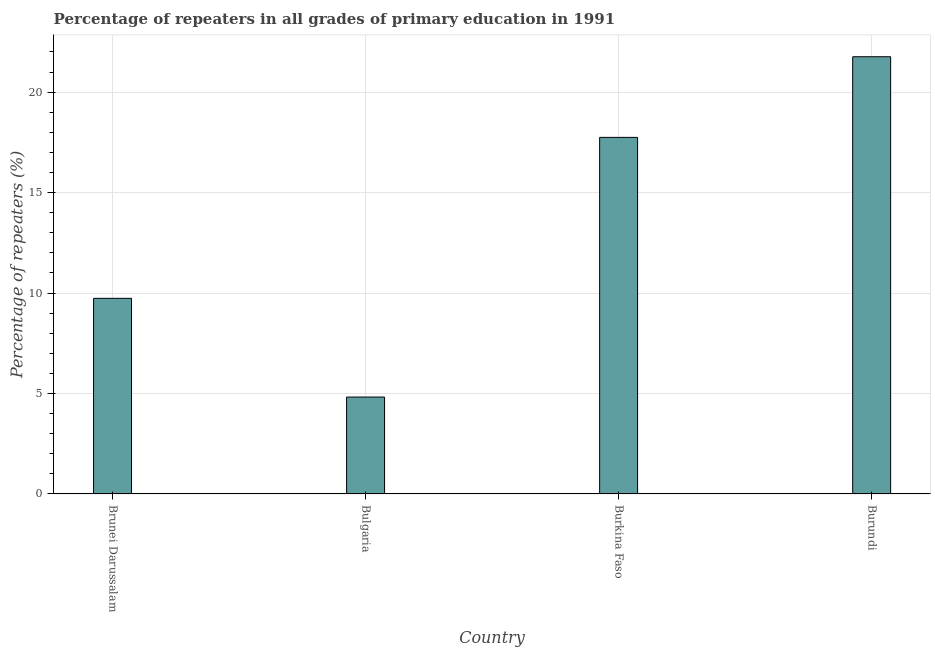Does the graph contain grids?
Offer a terse response. Yes. What is the title of the graph?
Offer a very short reply. Percentage of repeaters in all grades of primary education in 1991. What is the label or title of the Y-axis?
Ensure brevity in your answer.  Percentage of repeaters (%). What is the percentage of repeaters in primary education in Brunei Darussalam?
Offer a very short reply. 9.74. Across all countries, what is the maximum percentage of repeaters in primary education?
Keep it short and to the point. 21.76. Across all countries, what is the minimum percentage of repeaters in primary education?
Give a very brief answer. 4.82. In which country was the percentage of repeaters in primary education maximum?
Provide a succinct answer. Burundi. What is the sum of the percentage of repeaters in primary education?
Offer a terse response. 54.07. What is the difference between the percentage of repeaters in primary education in Brunei Darussalam and Burkina Faso?
Make the answer very short. -8.01. What is the average percentage of repeaters in primary education per country?
Your response must be concise. 13.52. What is the median percentage of repeaters in primary education?
Your answer should be very brief. 13.74. In how many countries, is the percentage of repeaters in primary education greater than 4 %?
Give a very brief answer. 4. What is the ratio of the percentage of repeaters in primary education in Brunei Darussalam to that in Burundi?
Provide a short and direct response. 0.45. Is the difference between the percentage of repeaters in primary education in Brunei Darussalam and Bulgaria greater than the difference between any two countries?
Make the answer very short. No. What is the difference between the highest and the second highest percentage of repeaters in primary education?
Give a very brief answer. 4.01. Is the sum of the percentage of repeaters in primary education in Bulgaria and Burkina Faso greater than the maximum percentage of repeaters in primary education across all countries?
Offer a terse response. Yes. What is the difference between the highest and the lowest percentage of repeaters in primary education?
Ensure brevity in your answer.  16.94. How many bars are there?
Offer a terse response. 4. Are all the bars in the graph horizontal?
Ensure brevity in your answer.  No. How many countries are there in the graph?
Ensure brevity in your answer.  4. What is the difference between two consecutive major ticks on the Y-axis?
Provide a short and direct response. 5. Are the values on the major ticks of Y-axis written in scientific E-notation?
Make the answer very short. No. What is the Percentage of repeaters (%) in Brunei Darussalam?
Your response must be concise. 9.74. What is the Percentage of repeaters (%) in Bulgaria?
Give a very brief answer. 4.82. What is the Percentage of repeaters (%) in Burkina Faso?
Make the answer very short. 17.75. What is the Percentage of repeaters (%) in Burundi?
Keep it short and to the point. 21.76. What is the difference between the Percentage of repeaters (%) in Brunei Darussalam and Bulgaria?
Make the answer very short. 4.91. What is the difference between the Percentage of repeaters (%) in Brunei Darussalam and Burkina Faso?
Your answer should be compact. -8.01. What is the difference between the Percentage of repeaters (%) in Brunei Darussalam and Burundi?
Keep it short and to the point. -12.03. What is the difference between the Percentage of repeaters (%) in Bulgaria and Burkina Faso?
Keep it short and to the point. -12.93. What is the difference between the Percentage of repeaters (%) in Bulgaria and Burundi?
Ensure brevity in your answer.  -16.94. What is the difference between the Percentage of repeaters (%) in Burkina Faso and Burundi?
Keep it short and to the point. -4.01. What is the ratio of the Percentage of repeaters (%) in Brunei Darussalam to that in Bulgaria?
Provide a short and direct response. 2.02. What is the ratio of the Percentage of repeaters (%) in Brunei Darussalam to that in Burkina Faso?
Your response must be concise. 0.55. What is the ratio of the Percentage of repeaters (%) in Brunei Darussalam to that in Burundi?
Offer a very short reply. 0.45. What is the ratio of the Percentage of repeaters (%) in Bulgaria to that in Burkina Faso?
Offer a very short reply. 0.27. What is the ratio of the Percentage of repeaters (%) in Bulgaria to that in Burundi?
Ensure brevity in your answer.  0.22. What is the ratio of the Percentage of repeaters (%) in Burkina Faso to that in Burundi?
Keep it short and to the point. 0.82. 